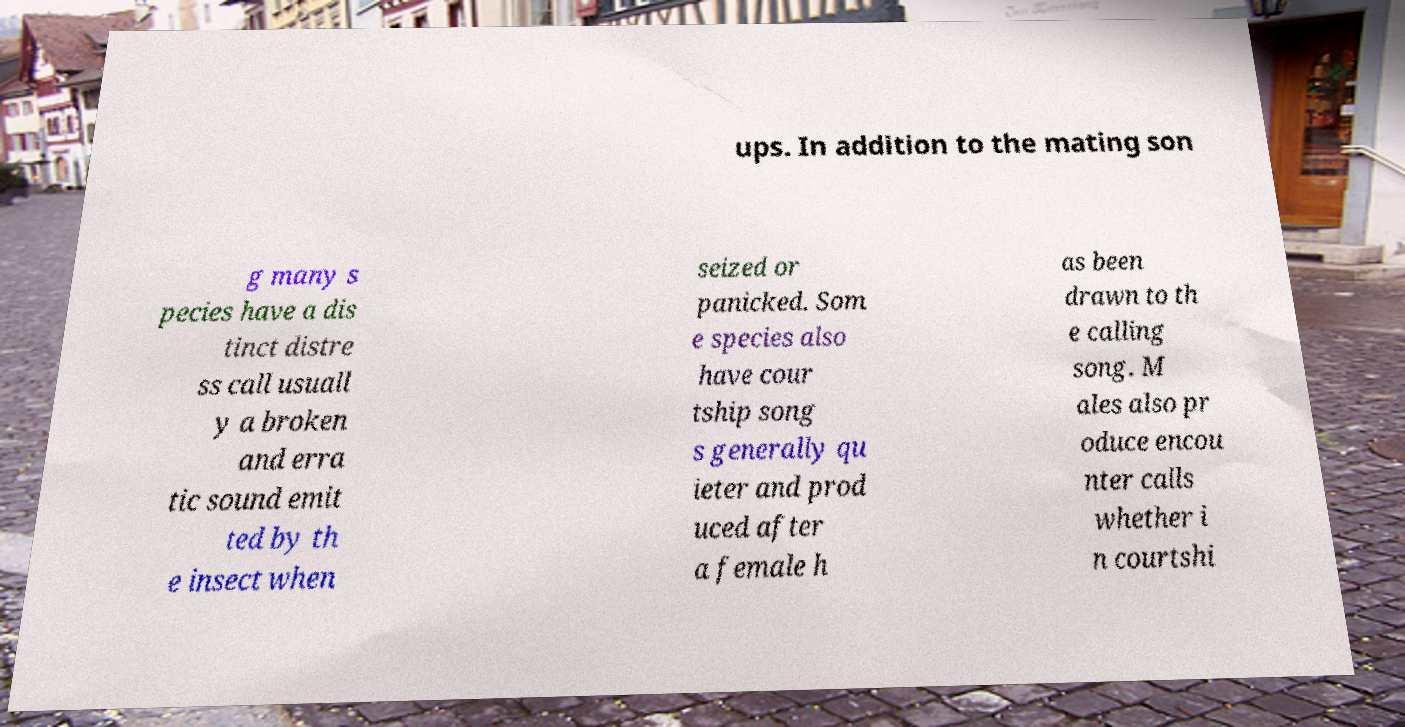Can you accurately transcribe the text from the provided image for me? ups. In addition to the mating son g many s pecies have a dis tinct distre ss call usuall y a broken and erra tic sound emit ted by th e insect when seized or panicked. Som e species also have cour tship song s generally qu ieter and prod uced after a female h as been drawn to th e calling song. M ales also pr oduce encou nter calls whether i n courtshi 